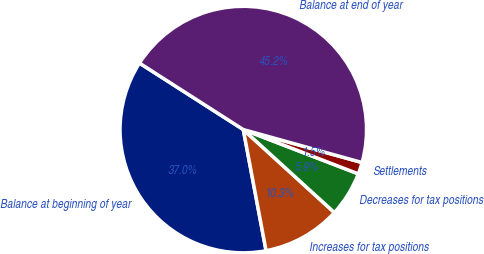Convert chart. <chart><loc_0><loc_0><loc_500><loc_500><pie_chart><fcel>Balance at beginning of year<fcel>Increases for tax positions<fcel>Decreases for tax positions<fcel>Settlements<fcel>Balance at end of year<nl><fcel>37.02%<fcel>10.28%<fcel>5.91%<fcel>1.54%<fcel>45.24%<nl></chart> 